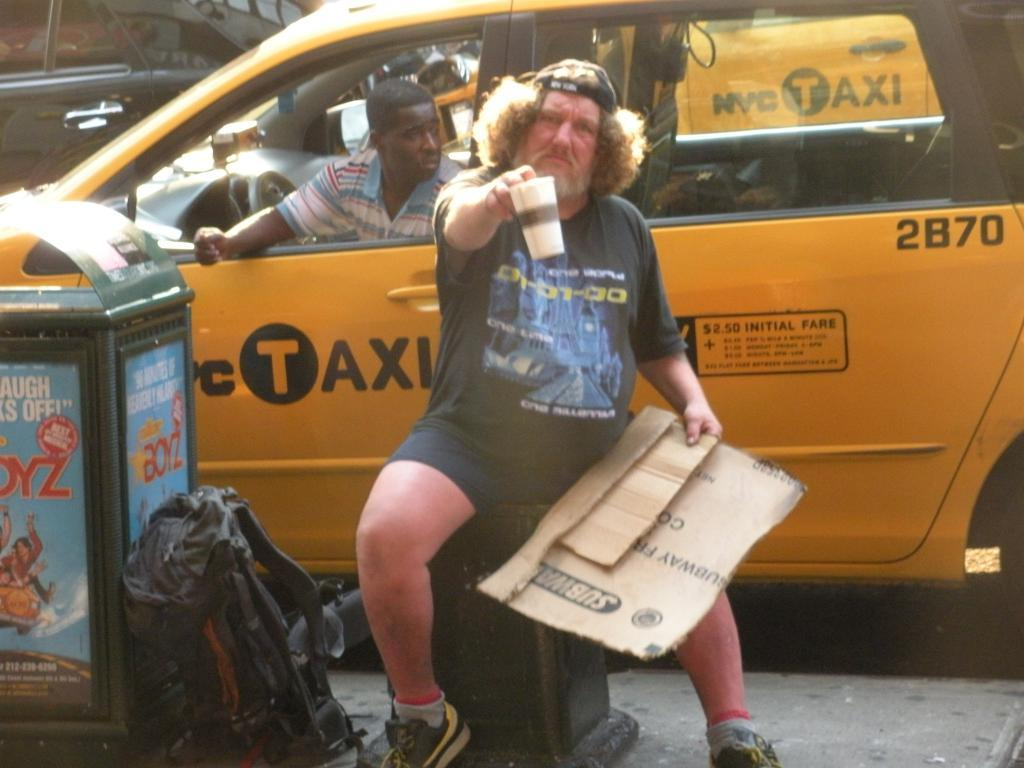<image>
Present a compact description of the photo's key features. The begger made his sign out of a Subway box. 